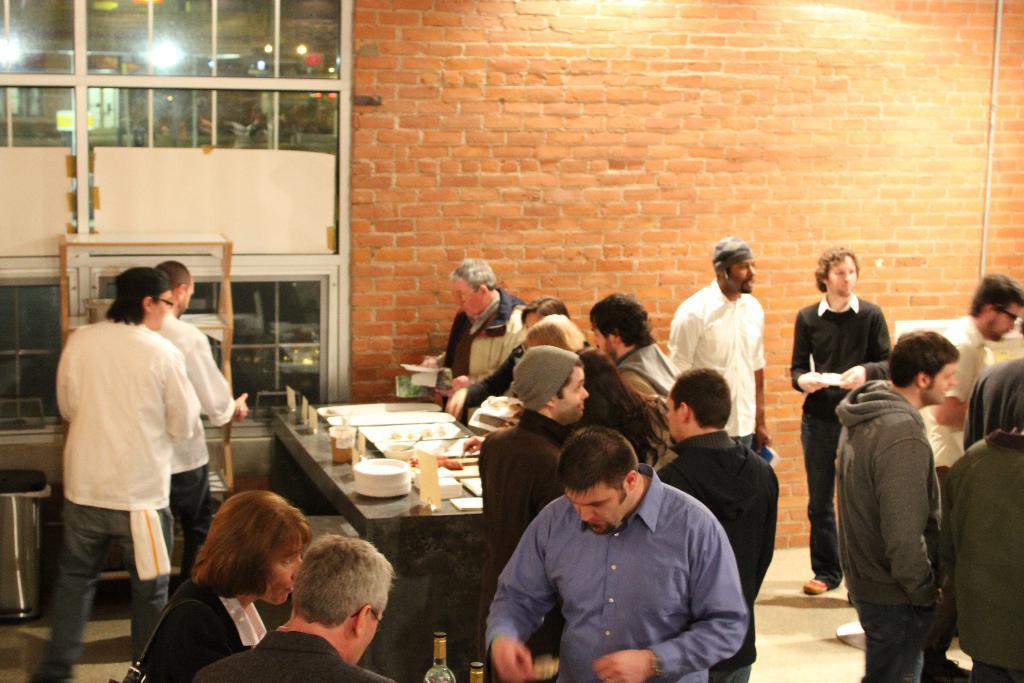Describe this image in one or two sentences. Here we can see a group of people standing here and there with tables in front of them and there are bottles and plates of food present on the table and the wall present here is in red color 